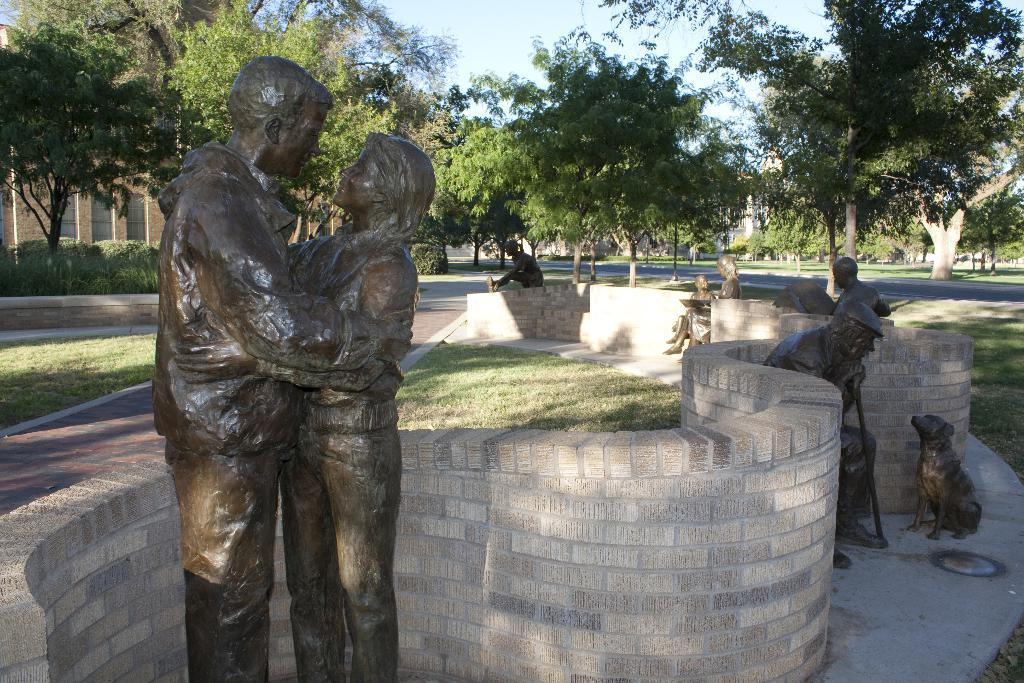What can be seen in the image that represents human-made structures? There are statues, a wall, and a building visible in the image. What type of natural elements can be seen in the background of the image? There is a tree, grass, and sky visible in the background of the image. What else can be seen in the background of the image? There is a road visible in the background of the image. Can you see any veins in the image? There are there any self-portraits of the artist? 